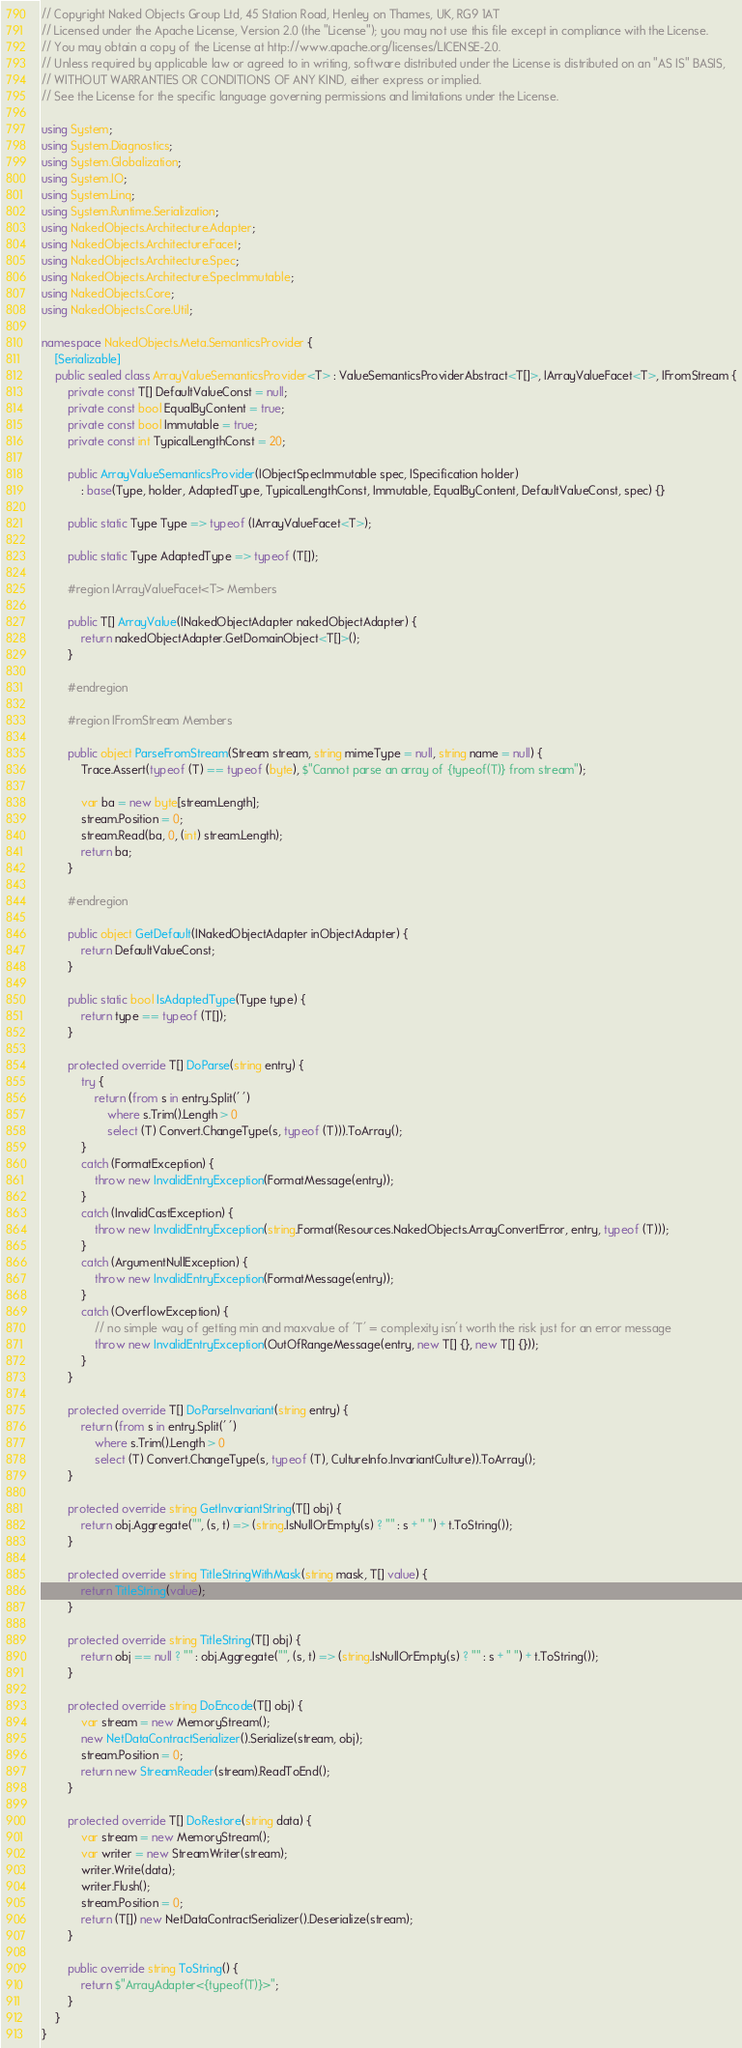<code> <loc_0><loc_0><loc_500><loc_500><_C#_>// Copyright Naked Objects Group Ltd, 45 Station Road, Henley on Thames, UK, RG9 1AT
// Licensed under the Apache License, Version 2.0 (the "License"); you may not use this file except in compliance with the License. 
// You may obtain a copy of the License at http://www.apache.org/licenses/LICENSE-2.0.
// Unless required by applicable law or agreed to in writing, software distributed under the License is distributed on an "AS IS" BASIS,
// WITHOUT WARRANTIES OR CONDITIONS OF ANY KIND, either express or implied.
// See the License for the specific language governing permissions and limitations under the License.

using System;
using System.Diagnostics;
using System.Globalization;
using System.IO;
using System.Linq;
using System.Runtime.Serialization;
using NakedObjects.Architecture.Adapter;
using NakedObjects.Architecture.Facet;
using NakedObjects.Architecture.Spec;
using NakedObjects.Architecture.SpecImmutable;
using NakedObjects.Core;
using NakedObjects.Core.Util;

namespace NakedObjects.Meta.SemanticsProvider {
    [Serializable]
    public sealed class ArrayValueSemanticsProvider<T> : ValueSemanticsProviderAbstract<T[]>, IArrayValueFacet<T>, IFromStream {
        private const T[] DefaultValueConst = null;
        private const bool EqualByContent = true;
        private const bool Immutable = true;
        private const int TypicalLengthConst = 20;

        public ArrayValueSemanticsProvider(IObjectSpecImmutable spec, ISpecification holder)
            : base(Type, holder, AdaptedType, TypicalLengthConst, Immutable, EqualByContent, DefaultValueConst, spec) {}

        public static Type Type => typeof (IArrayValueFacet<T>);

        public static Type AdaptedType => typeof (T[]);

        #region IArrayValueFacet<T> Members

        public T[] ArrayValue(INakedObjectAdapter nakedObjectAdapter) {
            return nakedObjectAdapter.GetDomainObject<T[]>();
        }

        #endregion

        #region IFromStream Members

        public object ParseFromStream(Stream stream, string mimeType = null, string name = null) {
            Trace.Assert(typeof (T) == typeof (byte), $"Cannot parse an array of {typeof(T)} from stream");

            var ba = new byte[stream.Length];
            stream.Position = 0;
            stream.Read(ba, 0, (int) stream.Length);
            return ba;
        }

        #endregion

        public object GetDefault(INakedObjectAdapter inObjectAdapter) {
            return DefaultValueConst;
        }

        public static bool IsAdaptedType(Type type) {
            return type == typeof (T[]);
        }

        protected override T[] DoParse(string entry) {
            try {
                return (from s in entry.Split(' ')
                    where s.Trim().Length > 0
                    select (T) Convert.ChangeType(s, typeof (T))).ToArray();
            }
            catch (FormatException) {
                throw new InvalidEntryException(FormatMessage(entry));
            }
            catch (InvalidCastException) {
                throw new InvalidEntryException(string.Format(Resources.NakedObjects.ArrayConvertError, entry, typeof (T)));
            }
            catch (ArgumentNullException) {
                throw new InvalidEntryException(FormatMessage(entry));
            }
            catch (OverflowException) {
                // no simple way of getting min and maxvalue of 'T' = complexity isn't worth the risk just for an error message
                throw new InvalidEntryException(OutOfRangeMessage(entry, new T[] {}, new T[] {}));
            }
        }

        protected override T[] DoParseInvariant(string entry) {
            return (from s in entry.Split(' ')
                where s.Trim().Length > 0
                select (T) Convert.ChangeType(s, typeof (T), CultureInfo.InvariantCulture)).ToArray();
        }

        protected override string GetInvariantString(T[] obj) {
            return obj.Aggregate("", (s, t) => (string.IsNullOrEmpty(s) ? "" : s + " ") + t.ToString());
        }

        protected override string TitleStringWithMask(string mask, T[] value) {
            return TitleString(value);
        }

        protected override string TitleString(T[] obj) {
            return obj == null ? "" : obj.Aggregate("", (s, t) => (string.IsNullOrEmpty(s) ? "" : s + " ") + t.ToString());
        }

        protected override string DoEncode(T[] obj) {
            var stream = new MemoryStream();
            new NetDataContractSerializer().Serialize(stream, obj);
            stream.Position = 0;
            return new StreamReader(stream).ReadToEnd();
        }

        protected override T[] DoRestore(string data) {
            var stream = new MemoryStream();
            var writer = new StreamWriter(stream);
            writer.Write(data);
            writer.Flush();
            stream.Position = 0;
            return (T[]) new NetDataContractSerializer().Deserialize(stream);
        }

        public override string ToString() {
            return $"ArrayAdapter<{typeof(T)}>";
        }
    }
}</code> 